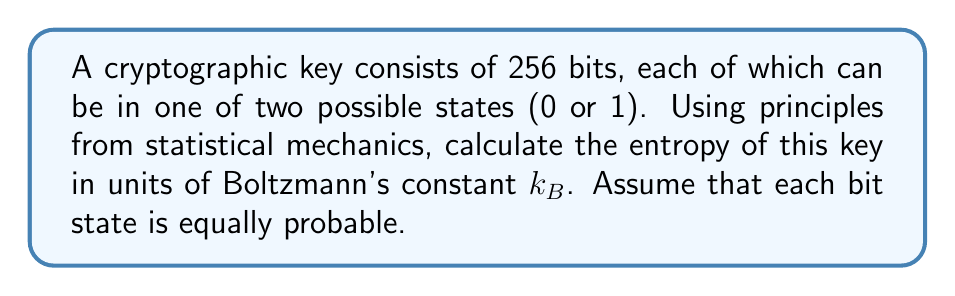Help me with this question. To determine the entropy of the cryptographic key using statistical mechanics principles, we'll follow these steps:

1) In statistical mechanics, the entropy $S$ is given by Boltzmann's formula:

   $$S = k_B \ln W$$

   where $k_B$ is Boltzmann's constant and $W$ is the number of microstates.

2) For a 256-bit key, each bit can be in one of two states (0 or 1). The total number of possible microstates is:

   $$W = 2^{256}$$

3) Substituting this into the entropy formula:

   $$S = k_B \ln(2^{256})$$

4) Using the logarithm property $\ln(a^b) = b\ln(a)$:

   $$S = k_B \cdot 256 \ln(2)$$

5) $\ln(2)$ is a constant approximately equal to 0.693. We can leave it as $\ln(2)$ for an exact answer.

6) Therefore, the final expression for entropy is:

   $$S = 256k_B\ln(2)$$

This result is in units of $k_B$, as requested in the question.
Answer: $256\ln(2)k_B$ 